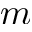<formula> <loc_0><loc_0><loc_500><loc_500>m</formula> 